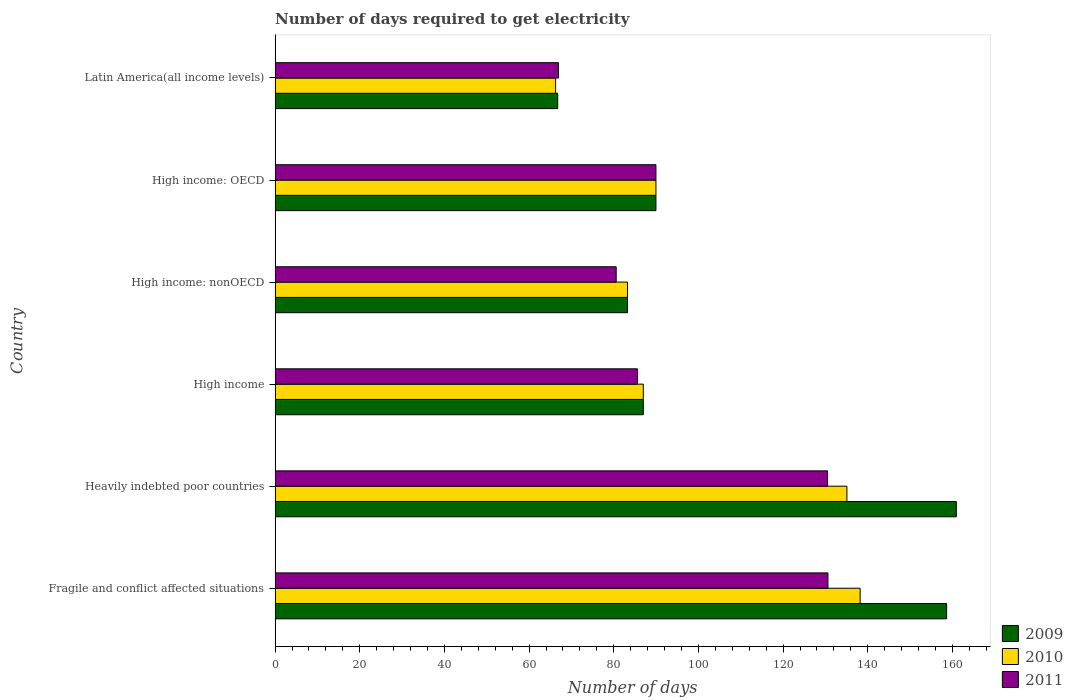How many groups of bars are there?
Your answer should be compact. 6. Are the number of bars per tick equal to the number of legend labels?
Provide a succinct answer. Yes. How many bars are there on the 4th tick from the bottom?
Offer a very short reply. 3. What is the label of the 6th group of bars from the top?
Offer a terse response. Fragile and conflict affected situations. What is the number of days required to get electricity in in 2009 in Latin America(all income levels)?
Your answer should be compact. 66.77. Across all countries, what is the maximum number of days required to get electricity in in 2011?
Keep it short and to the point. 130.6. Across all countries, what is the minimum number of days required to get electricity in in 2011?
Ensure brevity in your answer.  66.94. In which country was the number of days required to get electricity in in 2011 maximum?
Offer a terse response. Fragile and conflict affected situations. In which country was the number of days required to get electricity in in 2010 minimum?
Ensure brevity in your answer.  Latin America(all income levels). What is the total number of days required to get electricity in in 2011 in the graph?
Give a very brief answer. 584.19. What is the difference between the number of days required to get electricity in in 2009 in High income: OECD and that in Latin America(all income levels)?
Your response must be concise. 23.2. What is the difference between the number of days required to get electricity in in 2010 in Fragile and conflict affected situations and the number of days required to get electricity in in 2011 in High income: nonOECD?
Your answer should be very brief. 57.62. What is the average number of days required to get electricity in in 2009 per country?
Your response must be concise. 107.75. What is the difference between the number of days required to get electricity in in 2010 and number of days required to get electricity in in 2009 in Heavily indebted poor countries?
Keep it short and to the point. -25.84. In how many countries, is the number of days required to get electricity in in 2011 greater than 28 days?
Provide a short and direct response. 6. What is the ratio of the number of days required to get electricity in in 2009 in High income to that in High income: nonOECD?
Ensure brevity in your answer.  1.04. Is the difference between the number of days required to get electricity in in 2010 in Fragile and conflict affected situations and High income: OECD greater than the difference between the number of days required to get electricity in in 2009 in Fragile and conflict affected situations and High income: OECD?
Keep it short and to the point. No. What is the difference between the highest and the second highest number of days required to get electricity in in 2011?
Offer a terse response. 0.1. What is the difference between the highest and the lowest number of days required to get electricity in in 2011?
Provide a succinct answer. 63.66. In how many countries, is the number of days required to get electricity in in 2010 greater than the average number of days required to get electricity in in 2010 taken over all countries?
Your response must be concise. 2. Is it the case that in every country, the sum of the number of days required to get electricity in in 2009 and number of days required to get electricity in in 2010 is greater than the number of days required to get electricity in in 2011?
Your response must be concise. Yes. Are all the bars in the graph horizontal?
Keep it short and to the point. Yes. How many countries are there in the graph?
Your answer should be very brief. 6. What is the difference between two consecutive major ticks on the X-axis?
Offer a terse response. 20. Are the values on the major ticks of X-axis written in scientific E-notation?
Your answer should be very brief. No. Does the graph contain grids?
Your response must be concise. No. Where does the legend appear in the graph?
Offer a very short reply. Bottom right. How many legend labels are there?
Provide a short and direct response. 3. How are the legend labels stacked?
Offer a terse response. Vertical. What is the title of the graph?
Provide a short and direct response. Number of days required to get electricity. What is the label or title of the X-axis?
Make the answer very short. Number of days. What is the label or title of the Y-axis?
Provide a short and direct response. Country. What is the Number of days of 2009 in Fragile and conflict affected situations?
Keep it short and to the point. 158.63. What is the Number of days in 2010 in Fragile and conflict affected situations?
Offer a very short reply. 138.2. What is the Number of days of 2011 in Fragile and conflict affected situations?
Offer a terse response. 130.6. What is the Number of days of 2009 in Heavily indebted poor countries?
Your response must be concise. 160.92. What is the Number of days in 2010 in Heavily indebted poor countries?
Offer a very short reply. 135.08. What is the Number of days in 2011 in Heavily indebted poor countries?
Make the answer very short. 130.5. What is the Number of days in 2009 in High income?
Keep it short and to the point. 86.98. What is the Number of days in 2010 in High income?
Offer a terse response. 86.98. What is the Number of days of 2011 in High income?
Your response must be concise. 85.61. What is the Number of days in 2009 in High income: nonOECD?
Offer a very short reply. 83.25. What is the Number of days in 2010 in High income: nonOECD?
Your answer should be very brief. 83.25. What is the Number of days in 2011 in High income: nonOECD?
Make the answer very short. 80.58. What is the Number of days in 2009 in High income: OECD?
Your answer should be very brief. 89.97. What is the Number of days in 2010 in High income: OECD?
Give a very brief answer. 89.97. What is the Number of days of 2011 in High income: OECD?
Ensure brevity in your answer.  89.97. What is the Number of days in 2009 in Latin America(all income levels)?
Keep it short and to the point. 66.77. What is the Number of days of 2010 in Latin America(all income levels)?
Offer a terse response. 66.27. What is the Number of days of 2011 in Latin America(all income levels)?
Offer a very short reply. 66.94. Across all countries, what is the maximum Number of days of 2009?
Give a very brief answer. 160.92. Across all countries, what is the maximum Number of days in 2010?
Your answer should be compact. 138.2. Across all countries, what is the maximum Number of days in 2011?
Provide a succinct answer. 130.6. Across all countries, what is the minimum Number of days in 2009?
Offer a very short reply. 66.77. Across all countries, what is the minimum Number of days of 2010?
Offer a very short reply. 66.27. Across all countries, what is the minimum Number of days in 2011?
Provide a short and direct response. 66.94. What is the total Number of days in 2009 in the graph?
Make the answer very short. 646.52. What is the total Number of days in 2010 in the graph?
Make the answer very short. 599.74. What is the total Number of days in 2011 in the graph?
Ensure brevity in your answer.  584.19. What is the difference between the Number of days in 2009 in Fragile and conflict affected situations and that in Heavily indebted poor countries?
Make the answer very short. -2.29. What is the difference between the Number of days of 2010 in Fragile and conflict affected situations and that in Heavily indebted poor countries?
Give a very brief answer. 3.12. What is the difference between the Number of days of 2009 in Fragile and conflict affected situations and that in High income?
Offer a very short reply. 71.65. What is the difference between the Number of days of 2010 in Fragile and conflict affected situations and that in High income?
Ensure brevity in your answer.  51.22. What is the difference between the Number of days in 2011 in Fragile and conflict affected situations and that in High income?
Make the answer very short. 44.99. What is the difference between the Number of days in 2009 in Fragile and conflict affected situations and that in High income: nonOECD?
Keep it short and to the point. 75.38. What is the difference between the Number of days of 2010 in Fragile and conflict affected situations and that in High income: nonOECD?
Give a very brief answer. 54.95. What is the difference between the Number of days in 2011 in Fragile and conflict affected situations and that in High income: nonOECD?
Provide a short and direct response. 50.02. What is the difference between the Number of days in 2009 in Fragile and conflict affected situations and that in High income: OECD?
Ensure brevity in your answer.  68.67. What is the difference between the Number of days of 2010 in Fragile and conflict affected situations and that in High income: OECD?
Provide a short and direct response. 48.23. What is the difference between the Number of days in 2011 in Fragile and conflict affected situations and that in High income: OECD?
Ensure brevity in your answer.  40.63. What is the difference between the Number of days in 2009 in Fragile and conflict affected situations and that in Latin America(all income levels)?
Make the answer very short. 91.87. What is the difference between the Number of days in 2010 in Fragile and conflict affected situations and that in Latin America(all income levels)?
Ensure brevity in your answer.  71.93. What is the difference between the Number of days of 2011 in Fragile and conflict affected situations and that in Latin America(all income levels)?
Your answer should be very brief. 63.66. What is the difference between the Number of days of 2009 in Heavily indebted poor countries and that in High income?
Your answer should be compact. 73.94. What is the difference between the Number of days in 2010 in Heavily indebted poor countries and that in High income?
Your answer should be compact. 48.1. What is the difference between the Number of days in 2011 in Heavily indebted poor countries and that in High income?
Make the answer very short. 44.89. What is the difference between the Number of days of 2009 in Heavily indebted poor countries and that in High income: nonOECD?
Give a very brief answer. 77.67. What is the difference between the Number of days in 2010 in Heavily indebted poor countries and that in High income: nonOECD?
Your response must be concise. 51.83. What is the difference between the Number of days of 2011 in Heavily indebted poor countries and that in High income: nonOECD?
Provide a short and direct response. 49.92. What is the difference between the Number of days in 2009 in Heavily indebted poor countries and that in High income: OECD?
Offer a very short reply. 70.95. What is the difference between the Number of days of 2010 in Heavily indebted poor countries and that in High income: OECD?
Make the answer very short. 45.11. What is the difference between the Number of days in 2011 in Heavily indebted poor countries and that in High income: OECD?
Ensure brevity in your answer.  40.53. What is the difference between the Number of days of 2009 in Heavily indebted poor countries and that in Latin America(all income levels)?
Ensure brevity in your answer.  94.15. What is the difference between the Number of days in 2010 in Heavily indebted poor countries and that in Latin America(all income levels)?
Your answer should be compact. 68.81. What is the difference between the Number of days in 2011 in Heavily indebted poor countries and that in Latin America(all income levels)?
Keep it short and to the point. 63.56. What is the difference between the Number of days of 2009 in High income and that in High income: nonOECD?
Offer a very short reply. 3.73. What is the difference between the Number of days in 2010 in High income and that in High income: nonOECD?
Your answer should be very brief. 3.73. What is the difference between the Number of days of 2011 in High income and that in High income: nonOECD?
Make the answer very short. 5.03. What is the difference between the Number of days of 2009 in High income and that in High income: OECD?
Your answer should be very brief. -2.99. What is the difference between the Number of days in 2010 in High income and that in High income: OECD?
Make the answer very short. -2.99. What is the difference between the Number of days in 2011 in High income and that in High income: OECD?
Give a very brief answer. -4.36. What is the difference between the Number of days in 2009 in High income and that in Latin America(all income levels)?
Provide a succinct answer. 20.21. What is the difference between the Number of days in 2010 in High income and that in Latin America(all income levels)?
Offer a terse response. 20.71. What is the difference between the Number of days of 2011 in High income and that in Latin America(all income levels)?
Keep it short and to the point. 18.67. What is the difference between the Number of days of 2009 in High income: nonOECD and that in High income: OECD?
Give a very brief answer. -6.72. What is the difference between the Number of days of 2010 in High income: nonOECD and that in High income: OECD?
Provide a succinct answer. -6.72. What is the difference between the Number of days in 2011 in High income: nonOECD and that in High income: OECD?
Offer a very short reply. -9.39. What is the difference between the Number of days of 2009 in High income: nonOECD and that in Latin America(all income levels)?
Your response must be concise. 16.48. What is the difference between the Number of days in 2010 in High income: nonOECD and that in Latin America(all income levels)?
Give a very brief answer. 16.98. What is the difference between the Number of days of 2011 in High income: nonOECD and that in Latin America(all income levels)?
Offer a terse response. 13.64. What is the difference between the Number of days of 2009 in High income: OECD and that in Latin America(all income levels)?
Keep it short and to the point. 23.2. What is the difference between the Number of days in 2010 in High income: OECD and that in Latin America(all income levels)?
Offer a very short reply. 23.7. What is the difference between the Number of days in 2011 in High income: OECD and that in Latin America(all income levels)?
Keep it short and to the point. 23.03. What is the difference between the Number of days in 2009 in Fragile and conflict affected situations and the Number of days in 2010 in Heavily indebted poor countries?
Give a very brief answer. 23.55. What is the difference between the Number of days of 2009 in Fragile and conflict affected situations and the Number of days of 2011 in Heavily indebted poor countries?
Provide a short and direct response. 28.13. What is the difference between the Number of days of 2009 in Fragile and conflict affected situations and the Number of days of 2010 in High income?
Your response must be concise. 71.65. What is the difference between the Number of days in 2009 in Fragile and conflict affected situations and the Number of days in 2011 in High income?
Provide a short and direct response. 73.03. What is the difference between the Number of days in 2010 in Fragile and conflict affected situations and the Number of days in 2011 in High income?
Make the answer very short. 52.59. What is the difference between the Number of days in 2009 in Fragile and conflict affected situations and the Number of days in 2010 in High income: nonOECD?
Provide a succinct answer. 75.38. What is the difference between the Number of days of 2009 in Fragile and conflict affected situations and the Number of days of 2011 in High income: nonOECD?
Your answer should be compact. 78.06. What is the difference between the Number of days in 2010 in Fragile and conflict affected situations and the Number of days in 2011 in High income: nonOECD?
Provide a short and direct response. 57.62. What is the difference between the Number of days of 2009 in Fragile and conflict affected situations and the Number of days of 2010 in High income: OECD?
Keep it short and to the point. 68.67. What is the difference between the Number of days of 2009 in Fragile and conflict affected situations and the Number of days of 2011 in High income: OECD?
Offer a terse response. 68.67. What is the difference between the Number of days in 2010 in Fragile and conflict affected situations and the Number of days in 2011 in High income: OECD?
Your answer should be compact. 48.23. What is the difference between the Number of days in 2009 in Fragile and conflict affected situations and the Number of days in 2010 in Latin America(all income levels)?
Make the answer very short. 92.37. What is the difference between the Number of days in 2009 in Fragile and conflict affected situations and the Number of days in 2011 in Latin America(all income levels)?
Your answer should be very brief. 91.7. What is the difference between the Number of days in 2010 in Fragile and conflict affected situations and the Number of days in 2011 in Latin America(all income levels)?
Make the answer very short. 71.26. What is the difference between the Number of days in 2009 in Heavily indebted poor countries and the Number of days in 2010 in High income?
Your answer should be compact. 73.94. What is the difference between the Number of days in 2009 in Heavily indebted poor countries and the Number of days in 2011 in High income?
Provide a short and direct response. 75.31. What is the difference between the Number of days in 2010 in Heavily indebted poor countries and the Number of days in 2011 in High income?
Offer a terse response. 49.47. What is the difference between the Number of days of 2009 in Heavily indebted poor countries and the Number of days of 2010 in High income: nonOECD?
Give a very brief answer. 77.67. What is the difference between the Number of days of 2009 in Heavily indebted poor countries and the Number of days of 2011 in High income: nonOECD?
Provide a succinct answer. 80.34. What is the difference between the Number of days in 2010 in Heavily indebted poor countries and the Number of days in 2011 in High income: nonOECD?
Ensure brevity in your answer.  54.5. What is the difference between the Number of days in 2009 in Heavily indebted poor countries and the Number of days in 2010 in High income: OECD?
Ensure brevity in your answer.  70.95. What is the difference between the Number of days of 2009 in Heavily indebted poor countries and the Number of days of 2011 in High income: OECD?
Make the answer very short. 70.95. What is the difference between the Number of days in 2010 in Heavily indebted poor countries and the Number of days in 2011 in High income: OECD?
Your answer should be compact. 45.11. What is the difference between the Number of days of 2009 in Heavily indebted poor countries and the Number of days of 2010 in Latin America(all income levels)?
Your answer should be very brief. 94.65. What is the difference between the Number of days in 2009 in Heavily indebted poor countries and the Number of days in 2011 in Latin America(all income levels)?
Your answer should be compact. 93.99. What is the difference between the Number of days in 2010 in Heavily indebted poor countries and the Number of days in 2011 in Latin America(all income levels)?
Make the answer very short. 68.14. What is the difference between the Number of days of 2009 in High income and the Number of days of 2010 in High income: nonOECD?
Your response must be concise. 3.73. What is the difference between the Number of days in 2009 in High income and the Number of days in 2011 in High income: nonOECD?
Provide a short and direct response. 6.4. What is the difference between the Number of days in 2010 in High income and the Number of days in 2011 in High income: nonOECD?
Your answer should be compact. 6.4. What is the difference between the Number of days in 2009 in High income and the Number of days in 2010 in High income: OECD?
Your response must be concise. -2.99. What is the difference between the Number of days of 2009 in High income and the Number of days of 2011 in High income: OECD?
Your answer should be very brief. -2.99. What is the difference between the Number of days of 2010 in High income and the Number of days of 2011 in High income: OECD?
Ensure brevity in your answer.  -2.99. What is the difference between the Number of days in 2009 in High income and the Number of days in 2010 in Latin America(all income levels)?
Give a very brief answer. 20.71. What is the difference between the Number of days of 2009 in High income and the Number of days of 2011 in Latin America(all income levels)?
Make the answer very short. 20.05. What is the difference between the Number of days in 2010 in High income and the Number of days in 2011 in Latin America(all income levels)?
Your answer should be compact. 20.05. What is the difference between the Number of days in 2009 in High income: nonOECD and the Number of days in 2010 in High income: OECD?
Ensure brevity in your answer.  -6.72. What is the difference between the Number of days in 2009 in High income: nonOECD and the Number of days in 2011 in High income: OECD?
Offer a terse response. -6.72. What is the difference between the Number of days of 2010 in High income: nonOECD and the Number of days of 2011 in High income: OECD?
Make the answer very short. -6.72. What is the difference between the Number of days in 2009 in High income: nonOECD and the Number of days in 2010 in Latin America(all income levels)?
Ensure brevity in your answer.  16.98. What is the difference between the Number of days of 2009 in High income: nonOECD and the Number of days of 2011 in Latin America(all income levels)?
Keep it short and to the point. 16.31. What is the difference between the Number of days in 2010 in High income: nonOECD and the Number of days in 2011 in Latin America(all income levels)?
Your answer should be compact. 16.31. What is the difference between the Number of days in 2009 in High income: OECD and the Number of days in 2010 in Latin America(all income levels)?
Provide a short and direct response. 23.7. What is the difference between the Number of days in 2009 in High income: OECD and the Number of days in 2011 in Latin America(all income levels)?
Offer a terse response. 23.03. What is the difference between the Number of days of 2010 in High income: OECD and the Number of days of 2011 in Latin America(all income levels)?
Your response must be concise. 23.03. What is the average Number of days in 2009 per country?
Keep it short and to the point. 107.75. What is the average Number of days of 2010 per country?
Offer a terse response. 99.96. What is the average Number of days of 2011 per country?
Ensure brevity in your answer.  97.36. What is the difference between the Number of days of 2009 and Number of days of 2010 in Fragile and conflict affected situations?
Give a very brief answer. 20.43. What is the difference between the Number of days in 2009 and Number of days in 2011 in Fragile and conflict affected situations?
Provide a short and direct response. 28.03. What is the difference between the Number of days in 2010 and Number of days in 2011 in Fragile and conflict affected situations?
Provide a succinct answer. 7.6. What is the difference between the Number of days in 2009 and Number of days in 2010 in Heavily indebted poor countries?
Your answer should be very brief. 25.84. What is the difference between the Number of days in 2009 and Number of days in 2011 in Heavily indebted poor countries?
Ensure brevity in your answer.  30.42. What is the difference between the Number of days in 2010 and Number of days in 2011 in Heavily indebted poor countries?
Keep it short and to the point. 4.58. What is the difference between the Number of days in 2009 and Number of days in 2011 in High income?
Ensure brevity in your answer.  1.37. What is the difference between the Number of days in 2010 and Number of days in 2011 in High income?
Provide a short and direct response. 1.37. What is the difference between the Number of days in 2009 and Number of days in 2010 in High income: nonOECD?
Your response must be concise. 0. What is the difference between the Number of days in 2009 and Number of days in 2011 in High income: nonOECD?
Make the answer very short. 2.67. What is the difference between the Number of days of 2010 and Number of days of 2011 in High income: nonOECD?
Give a very brief answer. 2.67. What is the difference between the Number of days of 2009 and Number of days of 2010 in High income: OECD?
Provide a succinct answer. 0. What is the difference between the Number of days of 2009 and Number of days of 2011 in High income: OECD?
Give a very brief answer. 0. What is the difference between the Number of days in 2010 and Number of days in 2011 in High income: OECD?
Make the answer very short. 0. What is the difference between the Number of days of 2009 and Number of days of 2010 in Latin America(all income levels)?
Your response must be concise. 0.5. What is the difference between the Number of days in 2009 and Number of days in 2011 in Latin America(all income levels)?
Ensure brevity in your answer.  -0.17. What is the difference between the Number of days in 2010 and Number of days in 2011 in Latin America(all income levels)?
Your answer should be compact. -0.67. What is the ratio of the Number of days in 2009 in Fragile and conflict affected situations to that in Heavily indebted poor countries?
Your answer should be very brief. 0.99. What is the ratio of the Number of days of 2010 in Fragile and conflict affected situations to that in Heavily indebted poor countries?
Provide a succinct answer. 1.02. What is the ratio of the Number of days in 2009 in Fragile and conflict affected situations to that in High income?
Give a very brief answer. 1.82. What is the ratio of the Number of days in 2010 in Fragile and conflict affected situations to that in High income?
Make the answer very short. 1.59. What is the ratio of the Number of days of 2011 in Fragile and conflict affected situations to that in High income?
Keep it short and to the point. 1.53. What is the ratio of the Number of days of 2009 in Fragile and conflict affected situations to that in High income: nonOECD?
Provide a short and direct response. 1.91. What is the ratio of the Number of days of 2010 in Fragile and conflict affected situations to that in High income: nonOECD?
Keep it short and to the point. 1.66. What is the ratio of the Number of days in 2011 in Fragile and conflict affected situations to that in High income: nonOECD?
Offer a terse response. 1.62. What is the ratio of the Number of days of 2009 in Fragile and conflict affected situations to that in High income: OECD?
Your response must be concise. 1.76. What is the ratio of the Number of days in 2010 in Fragile and conflict affected situations to that in High income: OECD?
Keep it short and to the point. 1.54. What is the ratio of the Number of days in 2011 in Fragile and conflict affected situations to that in High income: OECD?
Offer a terse response. 1.45. What is the ratio of the Number of days of 2009 in Fragile and conflict affected situations to that in Latin America(all income levels)?
Offer a very short reply. 2.38. What is the ratio of the Number of days of 2010 in Fragile and conflict affected situations to that in Latin America(all income levels)?
Give a very brief answer. 2.09. What is the ratio of the Number of days in 2011 in Fragile and conflict affected situations to that in Latin America(all income levels)?
Your response must be concise. 1.95. What is the ratio of the Number of days of 2009 in Heavily indebted poor countries to that in High income?
Your answer should be compact. 1.85. What is the ratio of the Number of days in 2010 in Heavily indebted poor countries to that in High income?
Ensure brevity in your answer.  1.55. What is the ratio of the Number of days in 2011 in Heavily indebted poor countries to that in High income?
Your response must be concise. 1.52. What is the ratio of the Number of days in 2009 in Heavily indebted poor countries to that in High income: nonOECD?
Offer a very short reply. 1.93. What is the ratio of the Number of days in 2010 in Heavily indebted poor countries to that in High income: nonOECD?
Keep it short and to the point. 1.62. What is the ratio of the Number of days of 2011 in Heavily indebted poor countries to that in High income: nonOECD?
Offer a very short reply. 1.62. What is the ratio of the Number of days in 2009 in Heavily indebted poor countries to that in High income: OECD?
Offer a very short reply. 1.79. What is the ratio of the Number of days in 2010 in Heavily indebted poor countries to that in High income: OECD?
Your answer should be very brief. 1.5. What is the ratio of the Number of days of 2011 in Heavily indebted poor countries to that in High income: OECD?
Give a very brief answer. 1.45. What is the ratio of the Number of days of 2009 in Heavily indebted poor countries to that in Latin America(all income levels)?
Provide a succinct answer. 2.41. What is the ratio of the Number of days of 2010 in Heavily indebted poor countries to that in Latin America(all income levels)?
Ensure brevity in your answer.  2.04. What is the ratio of the Number of days of 2011 in Heavily indebted poor countries to that in Latin America(all income levels)?
Offer a very short reply. 1.95. What is the ratio of the Number of days in 2009 in High income to that in High income: nonOECD?
Give a very brief answer. 1.04. What is the ratio of the Number of days in 2010 in High income to that in High income: nonOECD?
Offer a terse response. 1.04. What is the ratio of the Number of days in 2011 in High income to that in High income: nonOECD?
Make the answer very short. 1.06. What is the ratio of the Number of days of 2009 in High income to that in High income: OECD?
Ensure brevity in your answer.  0.97. What is the ratio of the Number of days in 2010 in High income to that in High income: OECD?
Your answer should be very brief. 0.97. What is the ratio of the Number of days of 2011 in High income to that in High income: OECD?
Provide a succinct answer. 0.95. What is the ratio of the Number of days in 2009 in High income to that in Latin America(all income levels)?
Provide a short and direct response. 1.3. What is the ratio of the Number of days of 2010 in High income to that in Latin America(all income levels)?
Provide a succinct answer. 1.31. What is the ratio of the Number of days of 2011 in High income to that in Latin America(all income levels)?
Make the answer very short. 1.28. What is the ratio of the Number of days of 2009 in High income: nonOECD to that in High income: OECD?
Your response must be concise. 0.93. What is the ratio of the Number of days of 2010 in High income: nonOECD to that in High income: OECD?
Your response must be concise. 0.93. What is the ratio of the Number of days of 2011 in High income: nonOECD to that in High income: OECD?
Your answer should be very brief. 0.9. What is the ratio of the Number of days of 2009 in High income: nonOECD to that in Latin America(all income levels)?
Offer a terse response. 1.25. What is the ratio of the Number of days in 2010 in High income: nonOECD to that in Latin America(all income levels)?
Your response must be concise. 1.26. What is the ratio of the Number of days in 2011 in High income: nonOECD to that in Latin America(all income levels)?
Give a very brief answer. 1.2. What is the ratio of the Number of days in 2009 in High income: OECD to that in Latin America(all income levels)?
Ensure brevity in your answer.  1.35. What is the ratio of the Number of days in 2010 in High income: OECD to that in Latin America(all income levels)?
Give a very brief answer. 1.36. What is the ratio of the Number of days of 2011 in High income: OECD to that in Latin America(all income levels)?
Make the answer very short. 1.34. What is the difference between the highest and the second highest Number of days in 2009?
Offer a terse response. 2.29. What is the difference between the highest and the second highest Number of days of 2010?
Keep it short and to the point. 3.12. What is the difference between the highest and the lowest Number of days of 2009?
Provide a succinct answer. 94.15. What is the difference between the highest and the lowest Number of days in 2010?
Provide a short and direct response. 71.93. What is the difference between the highest and the lowest Number of days in 2011?
Make the answer very short. 63.66. 